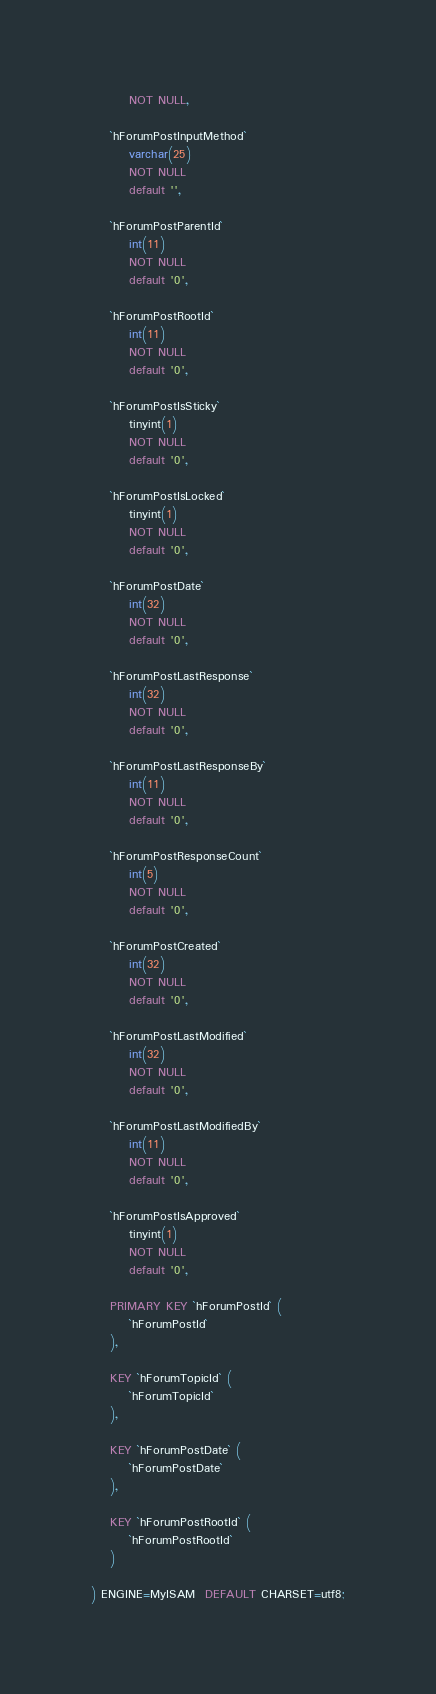<code> <loc_0><loc_0><loc_500><loc_500><_SQL_>        NOT NULL,

    `hForumPostInputMethod`
        varchar(25)
        NOT NULL
        default '',

    `hForumPostParentId`
        int(11)
        NOT NULL
        default '0',

    `hForumPostRootId`
        int(11)
        NOT NULL
        default '0',

    `hForumPostIsSticky`
        tinyint(1)
        NOT NULL
        default '0',

    `hForumPostIsLocked`
        tinyint(1)
        NOT NULL
        default '0',

    `hForumPostDate`
        int(32)
        NOT NULL
        default '0',

    `hForumPostLastResponse`
        int(32)
        NOT NULL
        default '0',

    `hForumPostLastResponseBy`
        int(11)
        NOT NULL
        default '0',

    `hForumPostResponseCount`
        int(5)
        NOT NULL
        default '0',

    `hForumPostCreated`
        int(32)
        NOT NULL
        default '0',

    `hForumPostLastModified`
        int(32)
        NOT NULL
        default '0',

    `hForumPostLastModifiedBy`
        int(11)
        NOT NULL
        default '0',

    `hForumPostIsApproved`
        tinyint(1)
        NOT NULL
        default '0',

    PRIMARY KEY `hForumPostId` (
        `hForumPostId`
    ),

    KEY `hForumTopicId` (
        `hForumTopicId`
    ),

    KEY `hForumPostDate` (
        `hForumPostDate`
    ),

    KEY `hForumPostRootId` (
        `hForumPostRootId`
    )

) ENGINE=MyISAM  DEFAULT CHARSET=utf8;</code> 